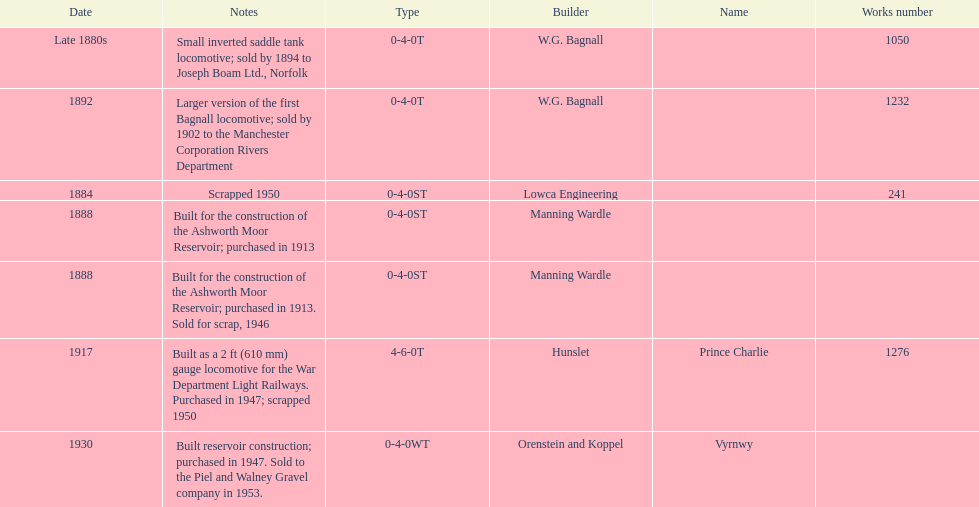How many locomotives were built after 1900? 2. 